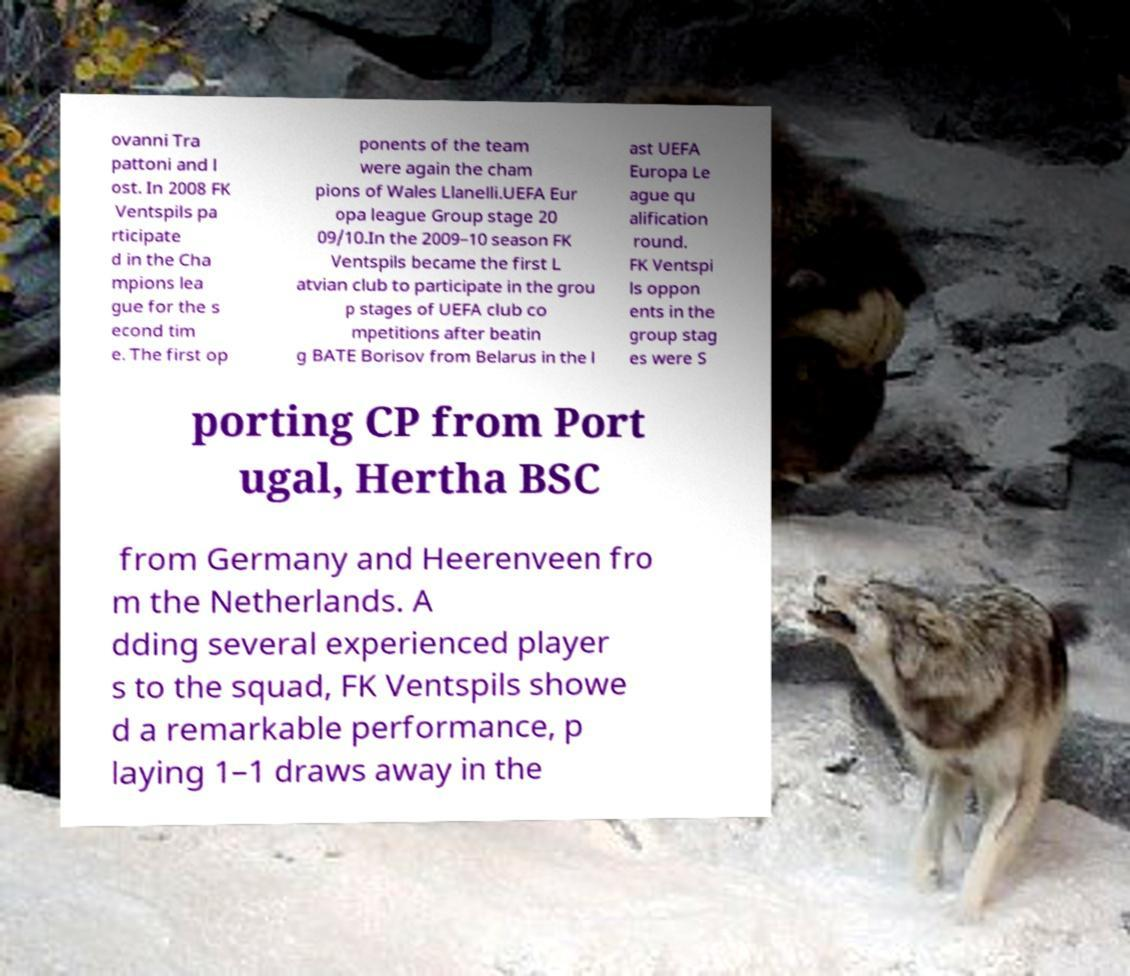Please read and relay the text visible in this image. What does it say? ovanni Tra pattoni and l ost. In 2008 FK Ventspils pa rticipate d in the Cha mpions lea gue for the s econd tim e. The first op ponents of the team were again the cham pions of Wales Llanelli.UEFA Eur opa league Group stage 20 09/10.In the 2009–10 season FK Ventspils became the first L atvian club to participate in the grou p stages of UEFA club co mpetitions after beatin g BATE Borisov from Belarus in the l ast UEFA Europa Le ague qu alification round. FK Ventspi ls oppon ents in the group stag es were S porting CP from Port ugal, Hertha BSC from Germany and Heerenveen fro m the Netherlands. A dding several experienced player s to the squad, FK Ventspils showe d a remarkable performance, p laying 1–1 draws away in the 